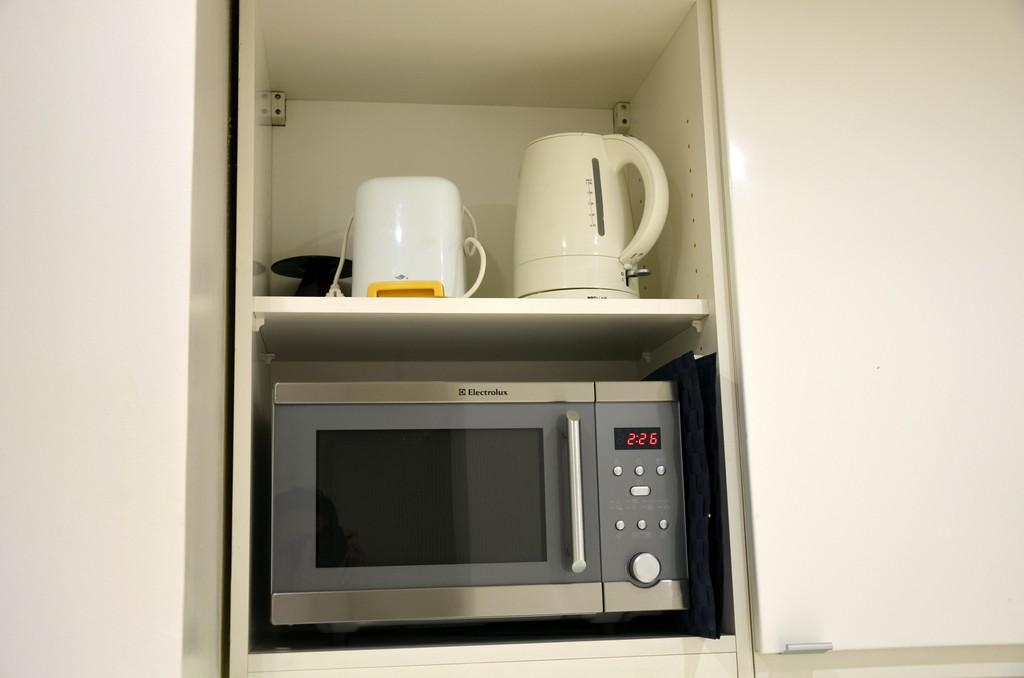<image>
Create a compact narrative representing the image presented. A microwave sitting inside a cabinet that shows the time as 2:26. 